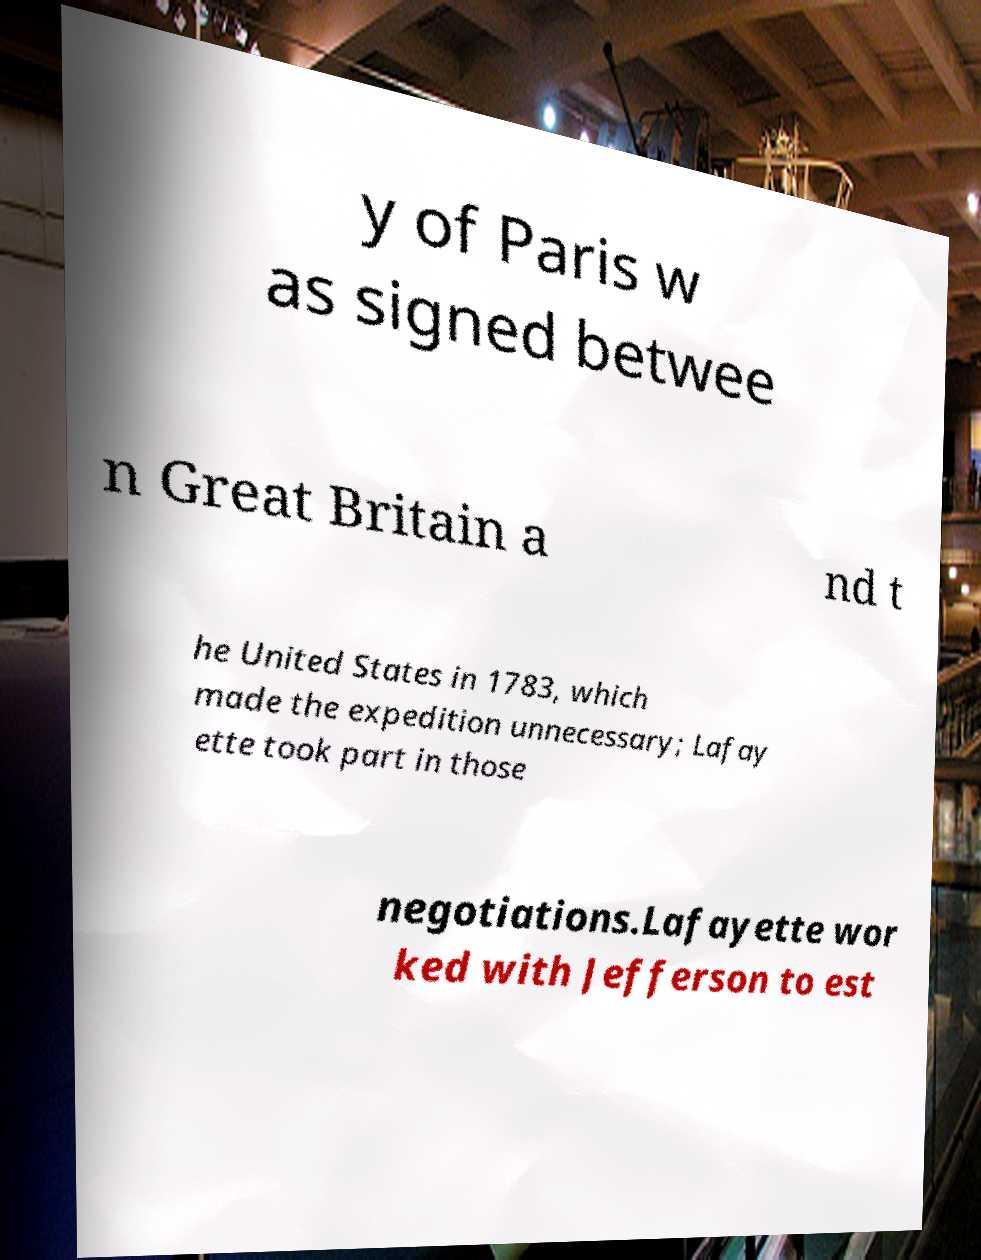Could you extract and type out the text from this image? y of Paris w as signed betwee n Great Britain a nd t he United States in 1783, which made the expedition unnecessary; Lafay ette took part in those negotiations.Lafayette wor ked with Jefferson to est 